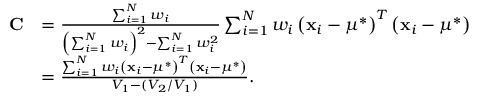Convert formula to latex. <formula><loc_0><loc_0><loc_500><loc_500>{ \begin{array} { r l } { C } & { = { \frac { \sum _ { i = 1 } ^ { N } w _ { i } } { \left ( \sum _ { i = 1 } ^ { N } w _ { i } \right ) ^ { 2 } - \sum _ { i = 1 } ^ { N } w _ { i } ^ { 2 } } } \sum _ { i = 1 } ^ { N } w _ { i } \left ( x _ { i } - \mu ^ { * } \right ) ^ { T } \left ( x _ { i } - \mu ^ { * } \right ) } \\ & { = { \frac { \sum _ { i = 1 } ^ { N } w _ { i } \left ( x _ { i } - \mu ^ { * } \right ) ^ { T } \left ( x _ { i } - \mu ^ { * } \right ) } { V _ { 1 } - ( V _ { 2 } / V _ { 1 } ) } } . } \end{array} }</formula> 